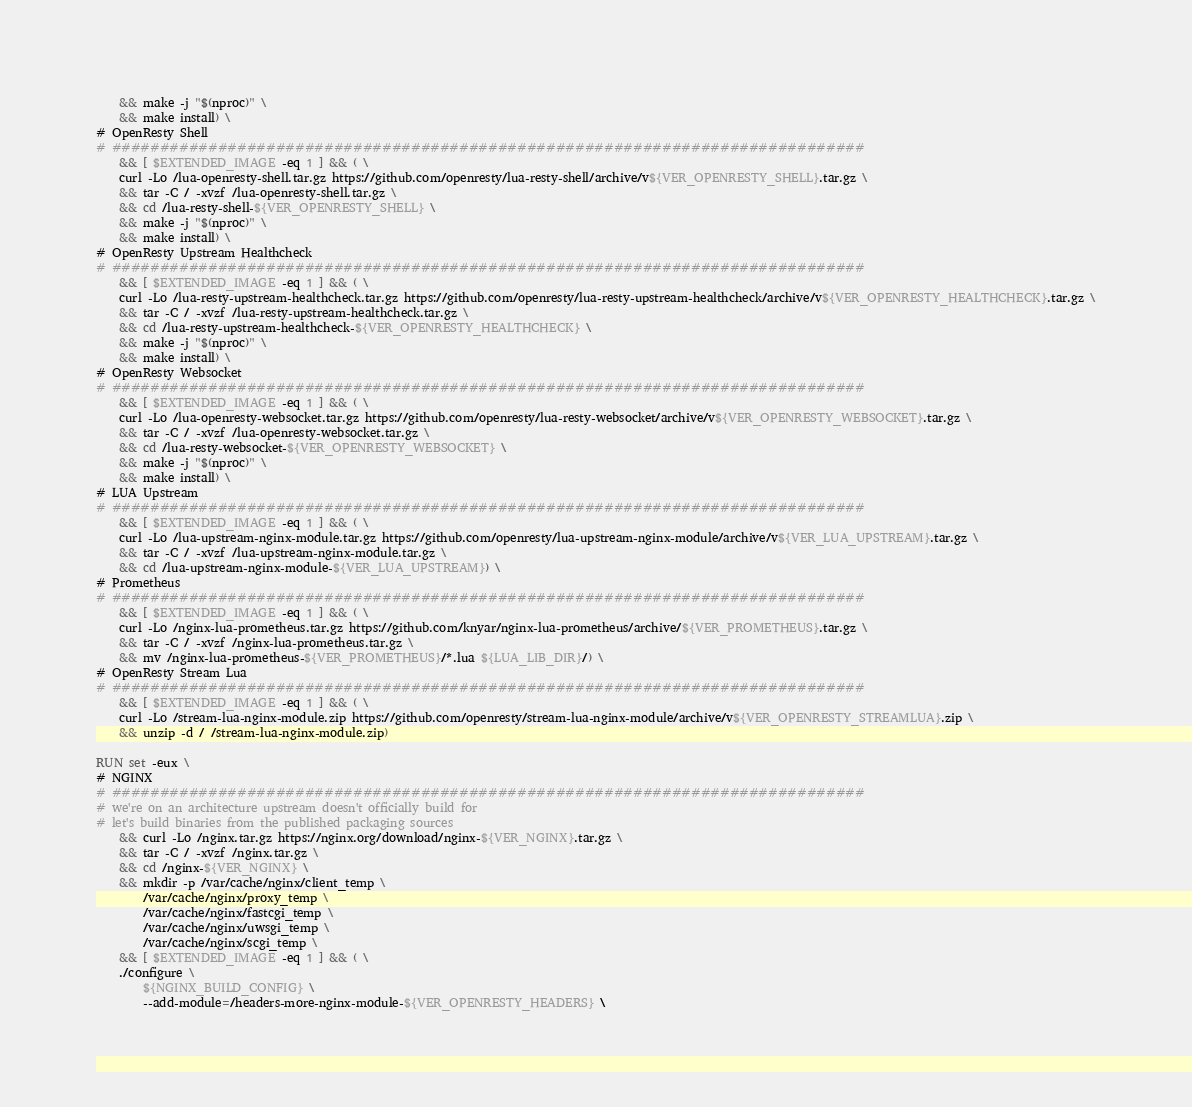Convert code to text. <code><loc_0><loc_0><loc_500><loc_500><_Dockerfile_>    && make -j "$(nproc)" \
    && make install) \
# OpenResty Shell
# ##############################################################################
    && [ $EXTENDED_IMAGE -eq 1 ] && ( \
    curl -Lo /lua-openresty-shell.tar.gz https://github.com/openresty/lua-resty-shell/archive/v${VER_OPENRESTY_SHELL}.tar.gz \
    && tar -C / -xvzf /lua-openresty-shell.tar.gz \
    && cd /lua-resty-shell-${VER_OPENRESTY_SHELL} \
    && make -j "$(nproc)" \
    && make install) \
# OpenResty Upstream Healthcheck
# ##############################################################################
    && [ $EXTENDED_IMAGE -eq 1 ] && ( \
    curl -Lo /lua-resty-upstream-healthcheck.tar.gz https://github.com/openresty/lua-resty-upstream-healthcheck/archive/v${VER_OPENRESTY_HEALTHCHECK}.tar.gz \
    && tar -C / -xvzf /lua-resty-upstream-healthcheck.tar.gz \
    && cd /lua-resty-upstream-healthcheck-${VER_OPENRESTY_HEALTHCHECK} \
    && make -j "$(nproc)" \
    && make install) \
# OpenResty Websocket
# ##############################################################################
    && [ $EXTENDED_IMAGE -eq 1 ] && ( \
    curl -Lo /lua-openresty-websocket.tar.gz https://github.com/openresty/lua-resty-websocket/archive/v${VER_OPENRESTY_WEBSOCKET}.tar.gz \
    && tar -C / -xvzf /lua-openresty-websocket.tar.gz \
    && cd /lua-resty-websocket-${VER_OPENRESTY_WEBSOCKET} \
    && make -j "$(nproc)" \
    && make install) \
# LUA Upstream
# ##############################################################################
    && [ $EXTENDED_IMAGE -eq 1 ] && ( \
    curl -Lo /lua-upstream-nginx-module.tar.gz https://github.com/openresty/lua-upstream-nginx-module/archive/v${VER_LUA_UPSTREAM}.tar.gz \
    && tar -C / -xvzf /lua-upstream-nginx-module.tar.gz \
    && cd /lua-upstream-nginx-module-${VER_LUA_UPSTREAM}) \
# Prometheus
# ##############################################################################
    && [ $EXTENDED_IMAGE -eq 1 ] && ( \
    curl -Lo /nginx-lua-prometheus.tar.gz https://github.com/knyar/nginx-lua-prometheus/archive/${VER_PROMETHEUS}.tar.gz \
    && tar -C / -xvzf /nginx-lua-prometheus.tar.gz \
    && mv /nginx-lua-prometheus-${VER_PROMETHEUS}/*.lua ${LUA_LIB_DIR}/) \
# OpenResty Stream Lua
# ##############################################################################
    && [ $EXTENDED_IMAGE -eq 1 ] && ( \
    curl -Lo /stream-lua-nginx-module.zip https://github.com/openresty/stream-lua-nginx-module/archive/v${VER_OPENRESTY_STREAMLUA}.zip \
    && unzip -d / /stream-lua-nginx-module.zip)

RUN set -eux \
# NGINX
# ##############################################################################
# we're on an architecture upstream doesn't officially build for
# let's build binaries from the published packaging sources
    && curl -Lo /nginx.tar.gz https://nginx.org/download/nginx-${VER_NGINX}.tar.gz \
    && tar -C / -xvzf /nginx.tar.gz \
    && cd /nginx-${VER_NGINX} \
    && mkdir -p /var/cache/nginx/client_temp \
        /var/cache/nginx/proxy_temp \
        /var/cache/nginx/fastcgi_temp \
        /var/cache/nginx/uwsgi_temp \
        /var/cache/nginx/scgi_temp \
    && [ $EXTENDED_IMAGE -eq 1 ] && ( \
    ./configure \
        ${NGINX_BUILD_CONFIG} \
        --add-module=/headers-more-nginx-module-${VER_OPENRESTY_HEADERS} \</code> 